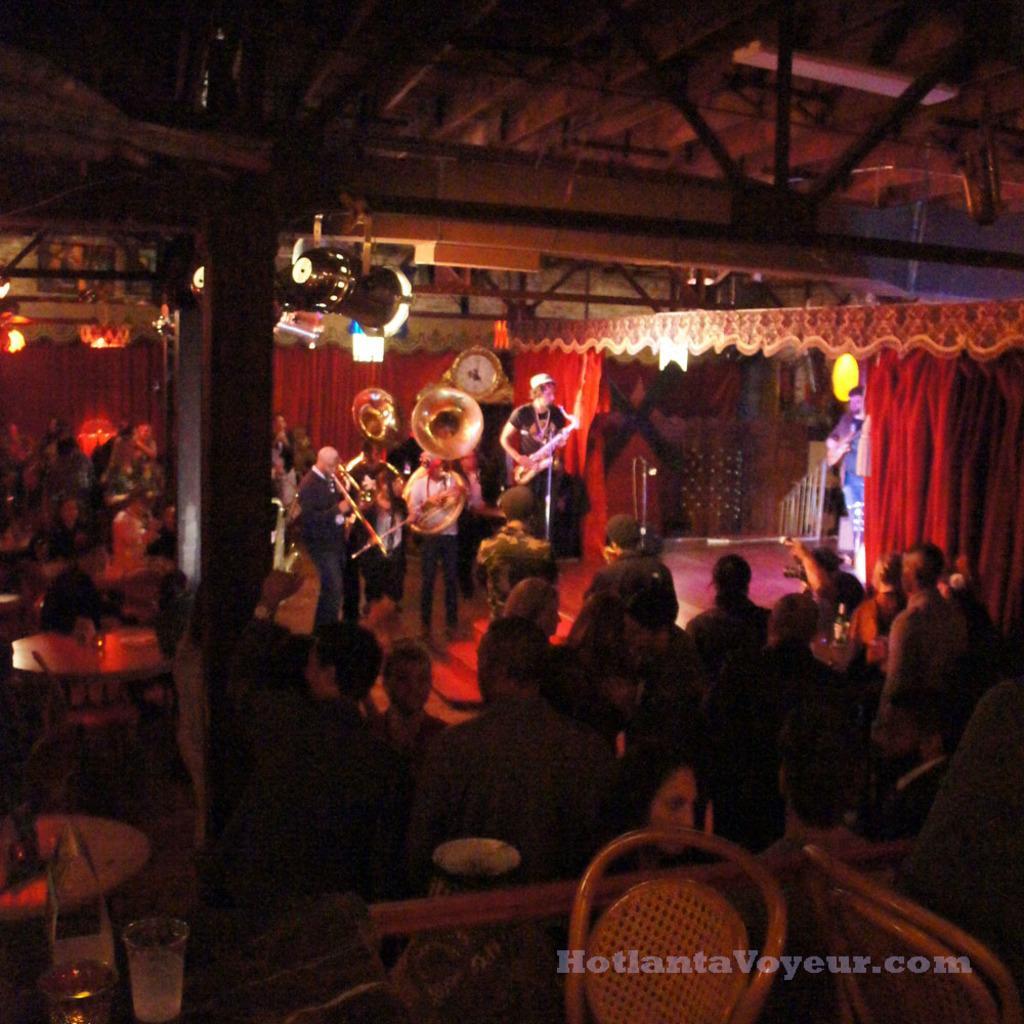Could you give a brief overview of what you see in this image? In this image we can see there are so many people standing and sitting in room, where some people playing musical instruments. Also there is a stage behind them and lights on the roof. 